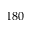Convert formula to latex. <formula><loc_0><loc_0><loc_500><loc_500>1 8 0</formula> 